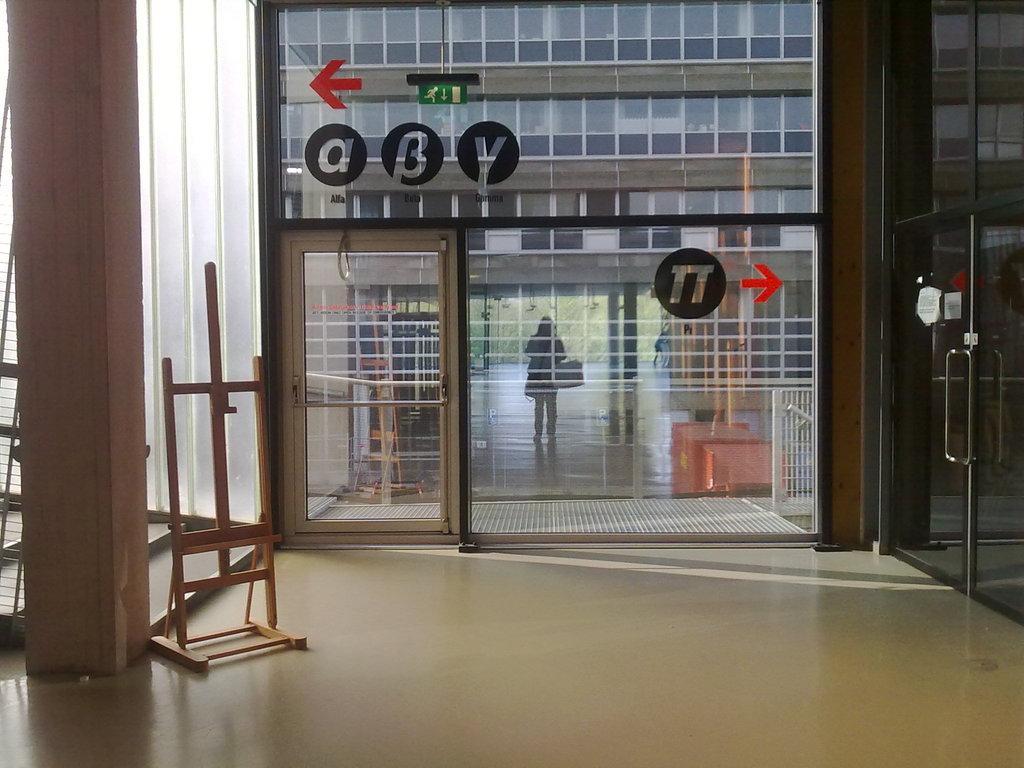Can you describe this image briefly? In this image there is a floor, in the background there is a glass wall, on that wall there is some text and there is a wooden stand and a pillar. 